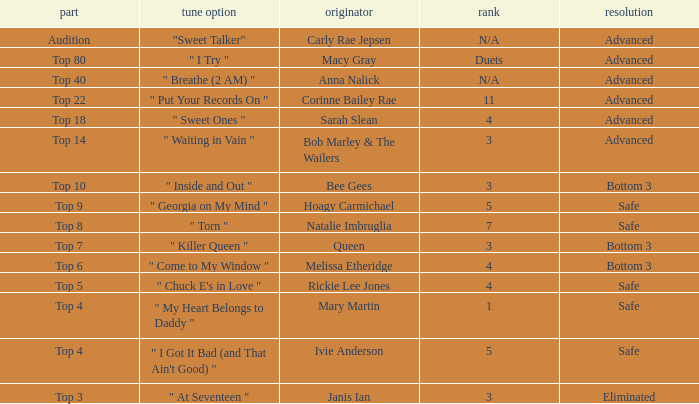Which one of the songs was originally performed by Rickie Lee Jones? " Chuck E's in Love ". 